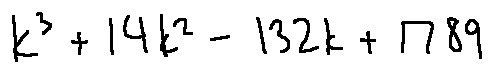<formula> <loc_0><loc_0><loc_500><loc_500>k ^ { 3 } + 1 4 k ^ { 2 } - 1 3 2 k + 1 7 8 9</formula> 